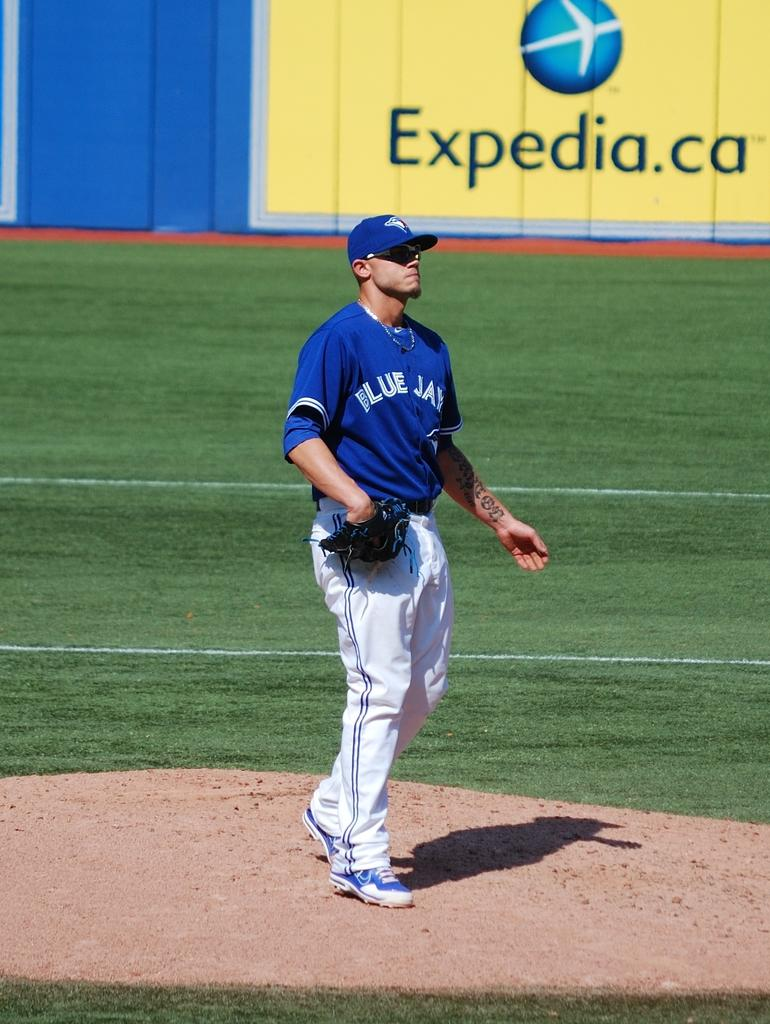Provide a one-sentence caption for the provided image. A baseball pitcher is standing in front of an ad for expedia.ca. 